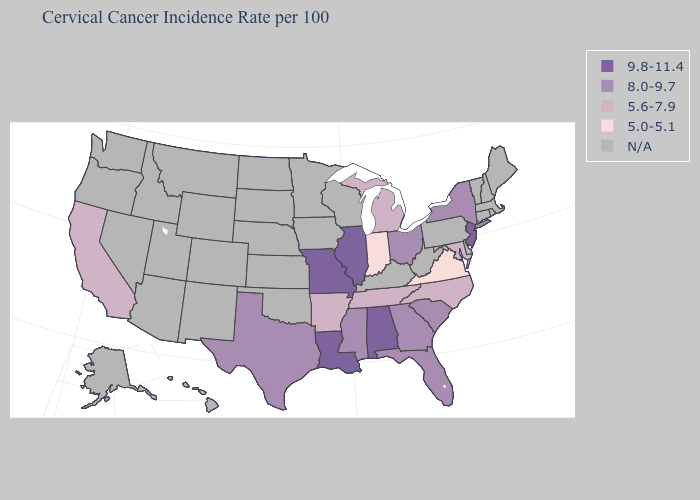Among the states that border Virginia , which have the highest value?
Write a very short answer. Maryland, North Carolina, Tennessee. Which states have the lowest value in the South?
Be succinct. Virginia. Among the states that border South Carolina , which have the lowest value?
Write a very short answer. North Carolina. Which states hav the highest value in the MidWest?
Concise answer only. Illinois, Missouri. Name the states that have a value in the range 9.8-11.4?
Quick response, please. Alabama, Illinois, Louisiana, Missouri, New Jersey. Among the states that border Missouri , which have the highest value?
Keep it brief. Illinois. Name the states that have a value in the range 8.0-9.7?
Give a very brief answer. Florida, Georgia, Mississippi, New York, Ohio, South Carolina, Texas. What is the value of Florida?
Short answer required. 8.0-9.7. Does New Jersey have the lowest value in the Northeast?
Write a very short answer. No. What is the value of Utah?
Quick response, please. N/A. Among the states that border Georgia , does Alabama have the highest value?
Write a very short answer. Yes. What is the value of Iowa?
Quick response, please. N/A. Among the states that border West Virginia , which have the highest value?
Keep it brief. Ohio. 